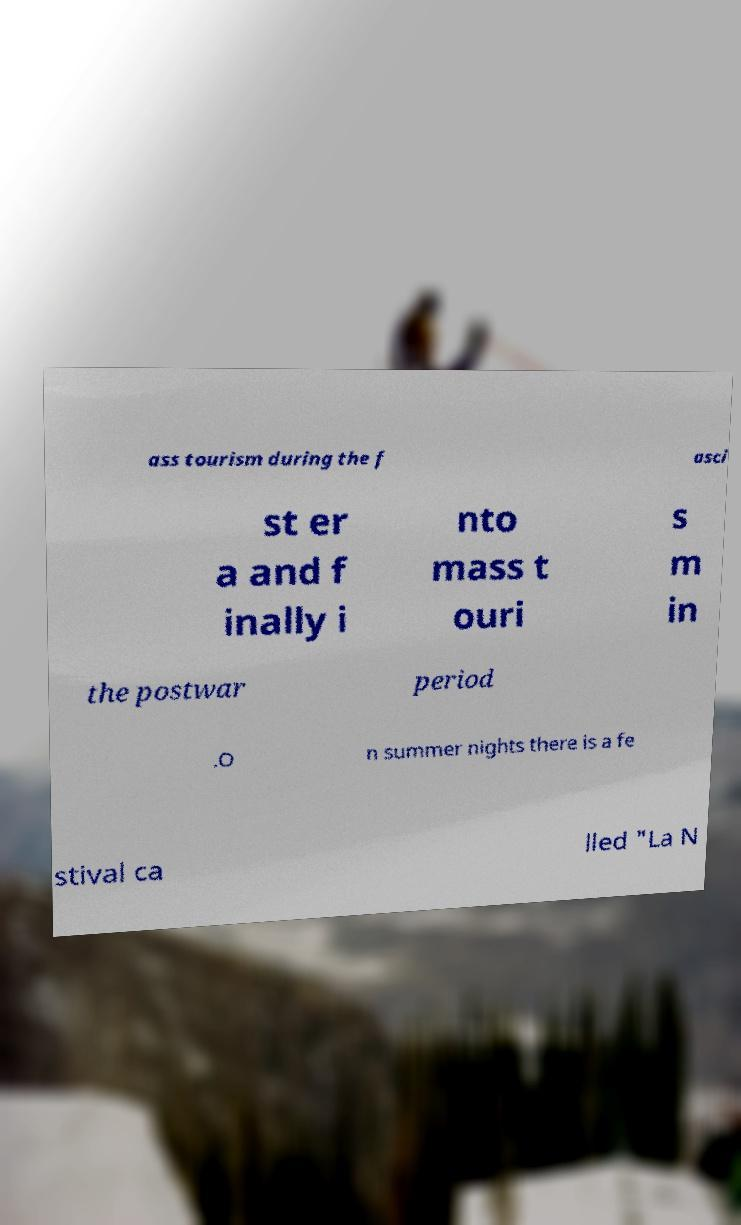There's text embedded in this image that I need extracted. Can you transcribe it verbatim? ass tourism during the f asci st er a and f inally i nto mass t ouri s m in the postwar period .O n summer nights there is a fe stival ca lled "La N 